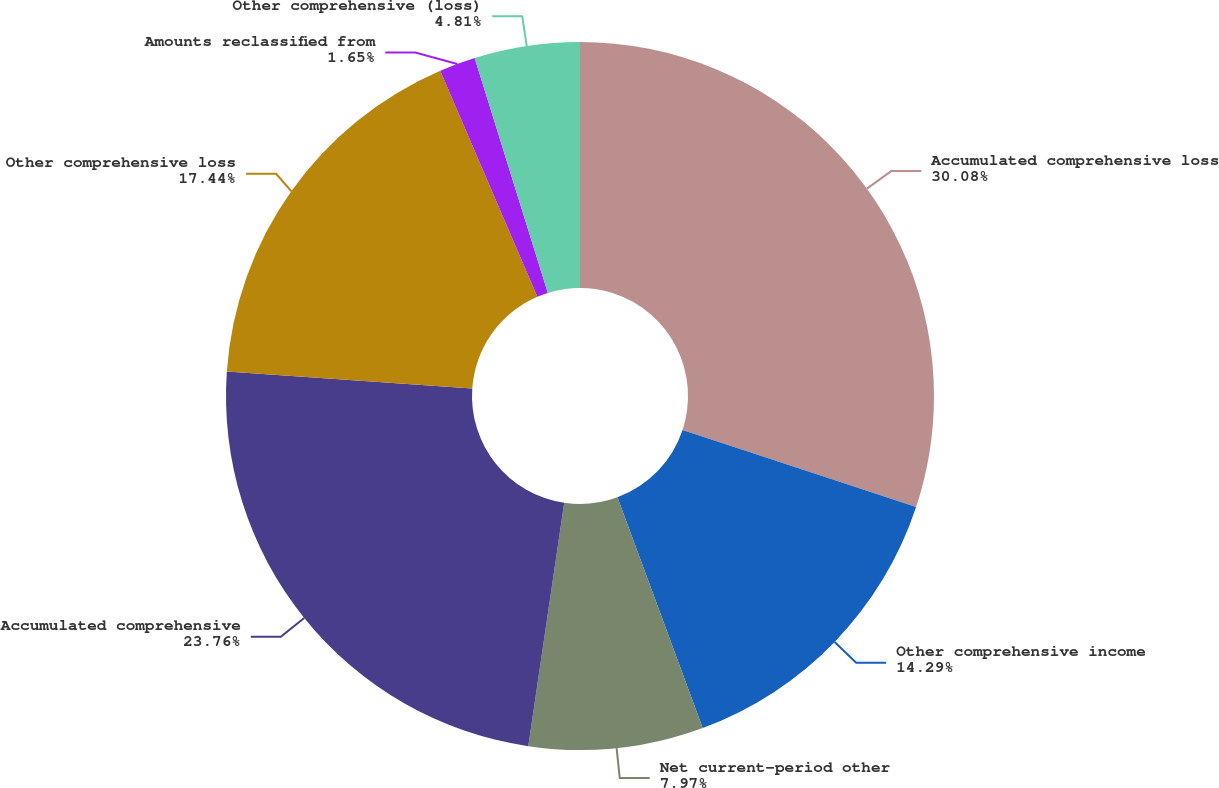<chart> <loc_0><loc_0><loc_500><loc_500><pie_chart><fcel>Accumulated comprehensive loss<fcel>Other comprehensive income<fcel>Net current-period other<fcel>Accumulated comprehensive<fcel>Other comprehensive loss<fcel>Amounts reclassified from<fcel>Other comprehensive (loss)<nl><fcel>30.09%<fcel>14.29%<fcel>7.97%<fcel>23.77%<fcel>17.45%<fcel>1.65%<fcel>4.81%<nl></chart> 